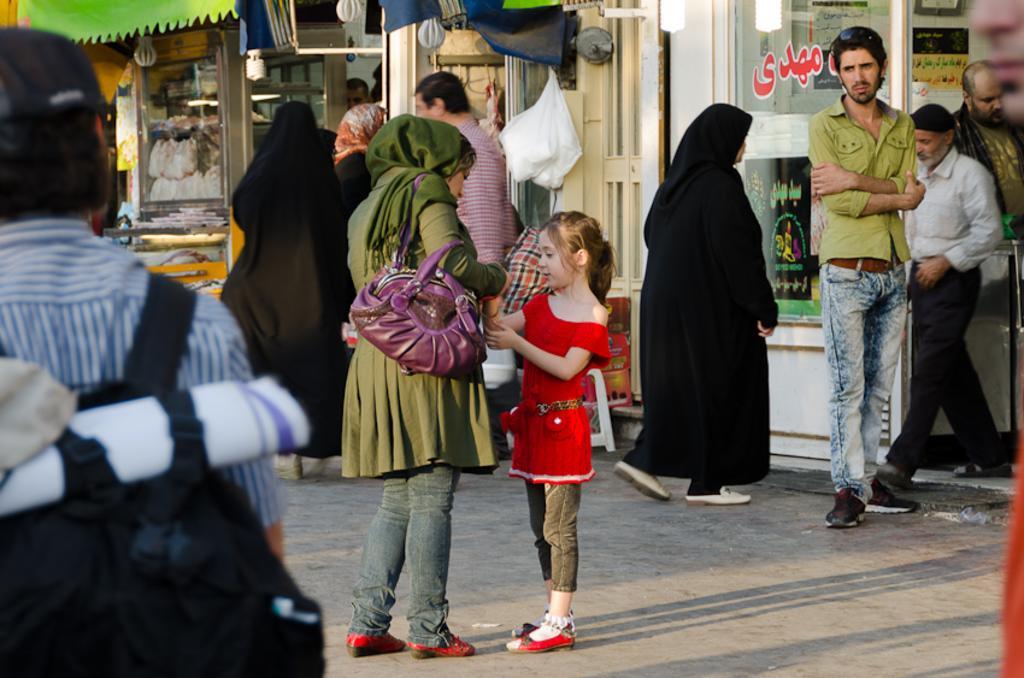How would you summarize this image in a sentence or two? In this image there are crowd of people visible in front of the building and a carry bag attached to the wall of the building 